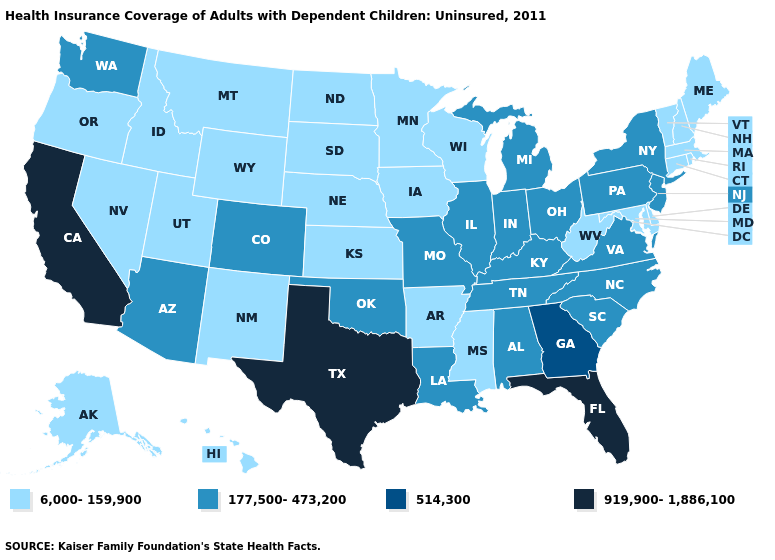What is the value of Alaska?
Keep it brief. 6,000-159,900. Name the states that have a value in the range 177,500-473,200?
Write a very short answer. Alabama, Arizona, Colorado, Illinois, Indiana, Kentucky, Louisiana, Michigan, Missouri, New Jersey, New York, North Carolina, Ohio, Oklahoma, Pennsylvania, South Carolina, Tennessee, Virginia, Washington. Name the states that have a value in the range 514,300?
Keep it brief. Georgia. What is the highest value in states that border Oregon?
Keep it brief. 919,900-1,886,100. Which states hav the highest value in the MidWest?
Keep it brief. Illinois, Indiana, Michigan, Missouri, Ohio. What is the highest value in the USA?
Answer briefly. 919,900-1,886,100. Which states hav the highest value in the MidWest?
Be succinct. Illinois, Indiana, Michigan, Missouri, Ohio. What is the lowest value in the MidWest?
Answer briefly. 6,000-159,900. Name the states that have a value in the range 514,300?
Keep it brief. Georgia. What is the highest value in the South ?
Short answer required. 919,900-1,886,100. Is the legend a continuous bar?
Give a very brief answer. No. Name the states that have a value in the range 6,000-159,900?
Give a very brief answer. Alaska, Arkansas, Connecticut, Delaware, Hawaii, Idaho, Iowa, Kansas, Maine, Maryland, Massachusetts, Minnesota, Mississippi, Montana, Nebraska, Nevada, New Hampshire, New Mexico, North Dakota, Oregon, Rhode Island, South Dakota, Utah, Vermont, West Virginia, Wisconsin, Wyoming. What is the lowest value in the USA?
Keep it brief. 6,000-159,900. Does New Hampshire have the same value as Maryland?
Write a very short answer. Yes. Which states hav the highest value in the South?
Short answer required. Florida, Texas. 